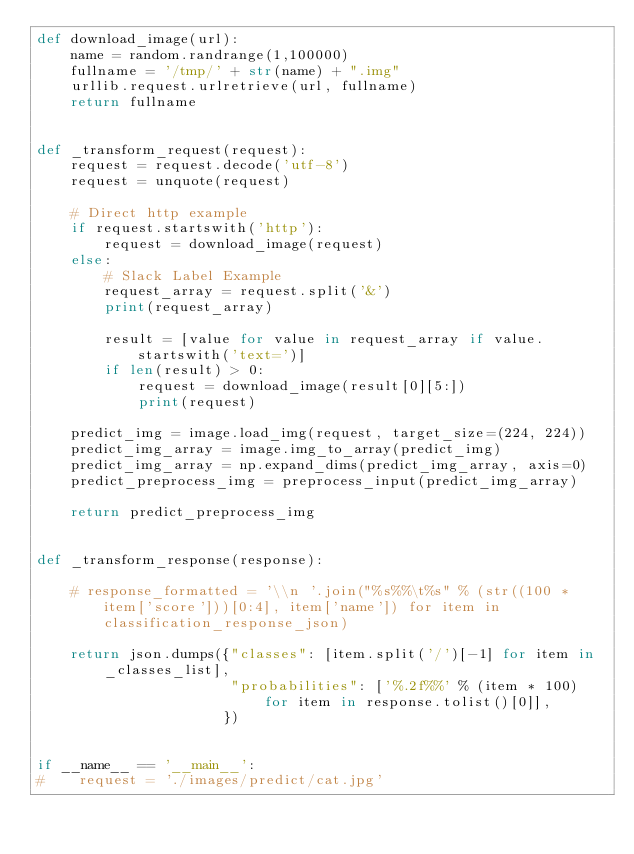Convert code to text. <code><loc_0><loc_0><loc_500><loc_500><_Python_>def download_image(url):
    name = random.randrange(1,100000)
    fullname = '/tmp/' + str(name) + ".img"
    urllib.request.urlretrieve(url, fullname)     
    return fullname


def _transform_request(request):
    request = request.decode('utf-8')
    request = unquote(request) 

    # Direct http example
    if request.startswith('http'):
        request = download_image(request)
    else:
        # Slack Label Example
        request_array = request.split('&')
        print(request_array)

        result = [value for value in request_array if value.startswith('text=')]
        if len(result) > 0:
            request = download_image(result[0][5:])
            print(request)
               
    predict_img = image.load_img(request, target_size=(224, 224))
    predict_img_array = image.img_to_array(predict_img)
    predict_img_array = np.expand_dims(predict_img_array, axis=0)
    predict_preprocess_img = preprocess_input(predict_img_array)

    return predict_preprocess_img


def _transform_response(response):

    # response_formatted = '\\n '.join("%s%%\t%s" % (str((100 * item['score']))[0:4], item['name']) for item in classification_response_json)

    return json.dumps({"classes": [item.split('/')[-1] for item in _classes_list], 
                       "probabilities": ['%.2f%%' % (item * 100) for item in response.tolist()[0]],
                      })


if __name__ == '__main__':
#    request = './images/predict/cat.jpg'</code> 